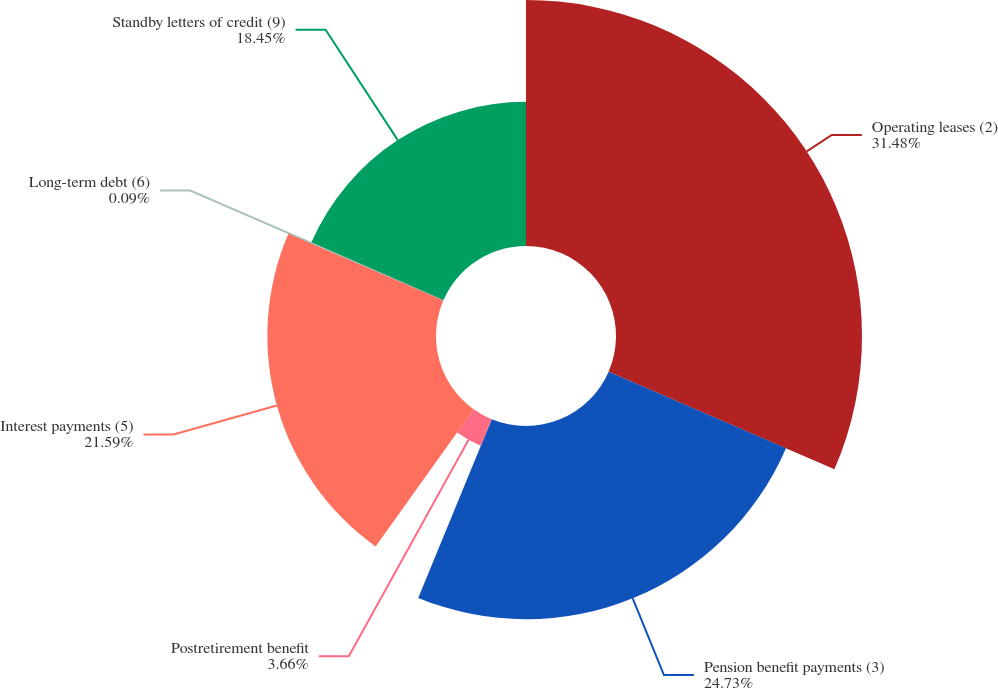Convert chart. <chart><loc_0><loc_0><loc_500><loc_500><pie_chart><fcel>Operating leases (2)<fcel>Pension benefit payments (3)<fcel>Postretirement benefit<fcel>Interest payments (5)<fcel>Long-term debt (6)<fcel>Standby letters of credit (9)<nl><fcel>31.49%<fcel>24.73%<fcel>3.66%<fcel>21.59%<fcel>0.09%<fcel>18.45%<nl></chart> 